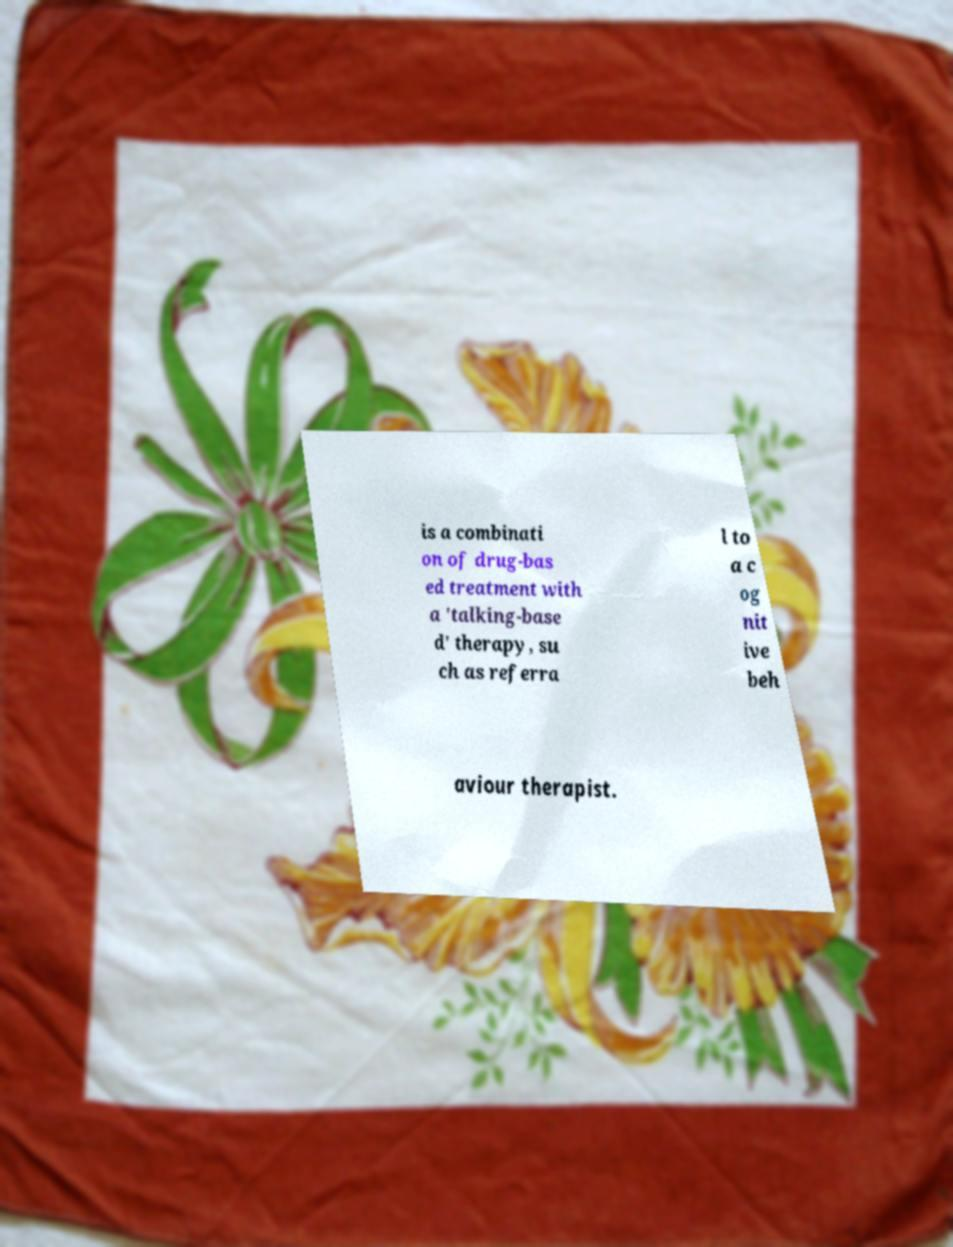Can you accurately transcribe the text from the provided image for me? is a combinati on of drug-bas ed treatment with a 'talking-base d' therapy, su ch as referra l to a c og nit ive beh aviour therapist. 